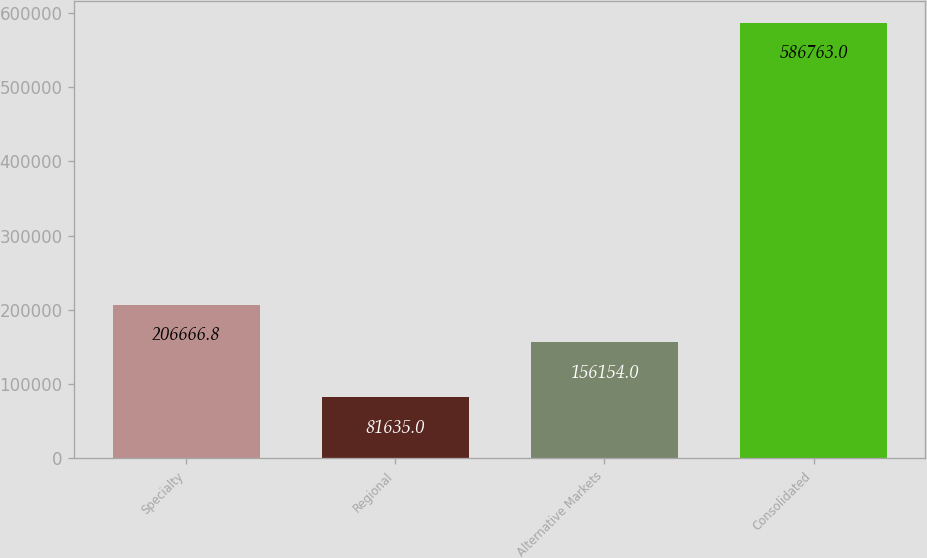Convert chart. <chart><loc_0><loc_0><loc_500><loc_500><bar_chart><fcel>Specialty<fcel>Regional<fcel>Alternative Markets<fcel>Consolidated<nl><fcel>206667<fcel>81635<fcel>156154<fcel>586763<nl></chart> 